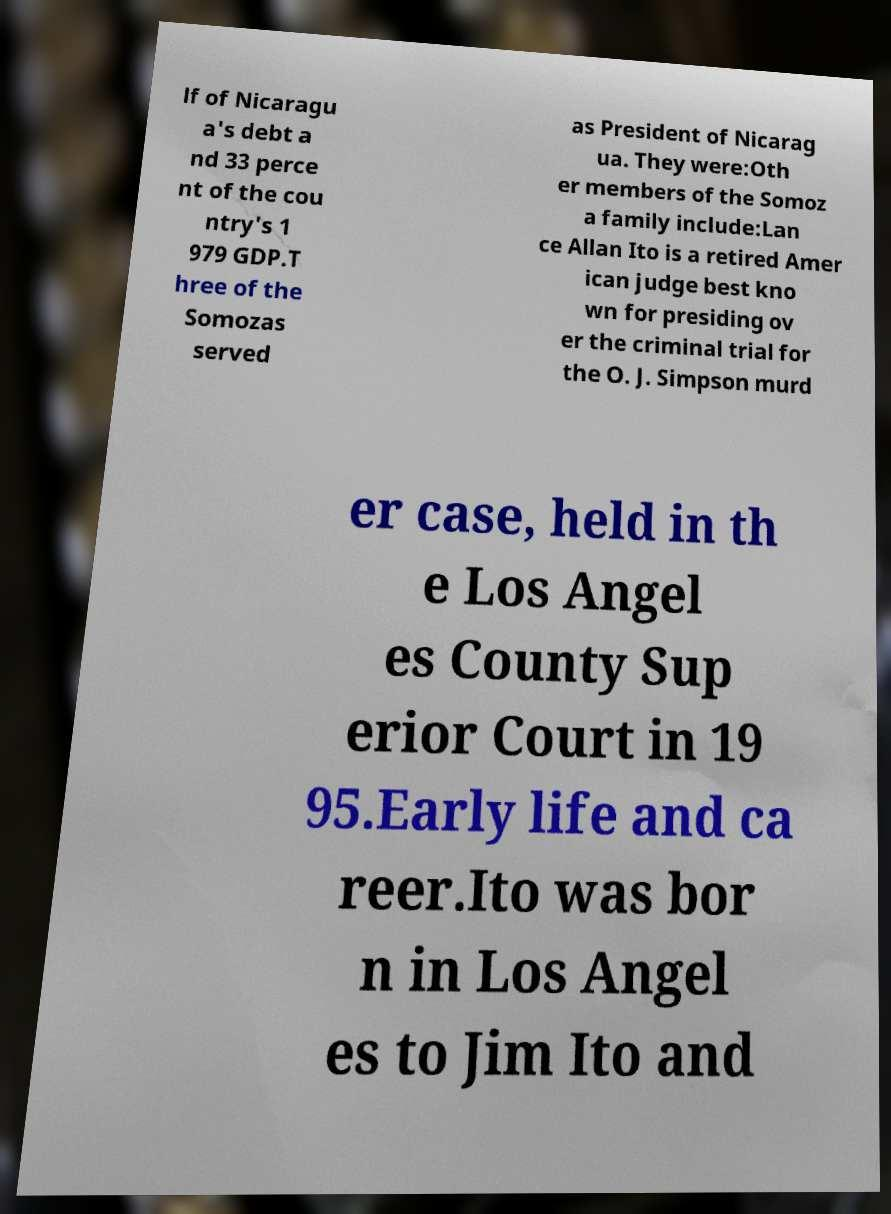Please identify and transcribe the text found in this image. lf of Nicaragu a's debt a nd 33 perce nt of the cou ntry's 1 979 GDP.T hree of the Somozas served as President of Nicarag ua. They were:Oth er members of the Somoz a family include:Lan ce Allan Ito is a retired Amer ican judge best kno wn for presiding ov er the criminal trial for the O. J. Simpson murd er case, held in th e Los Angel es County Sup erior Court in 19 95.Early life and ca reer.Ito was bor n in Los Angel es to Jim Ito and 